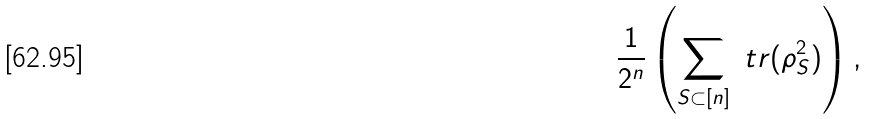<formula> <loc_0><loc_0><loc_500><loc_500>\frac { 1 } { 2 ^ { n } } \left ( \sum _ { S \subset [ n ] } \ t r ( \rho _ { S } ^ { 2 } ) \right ) ,</formula> 